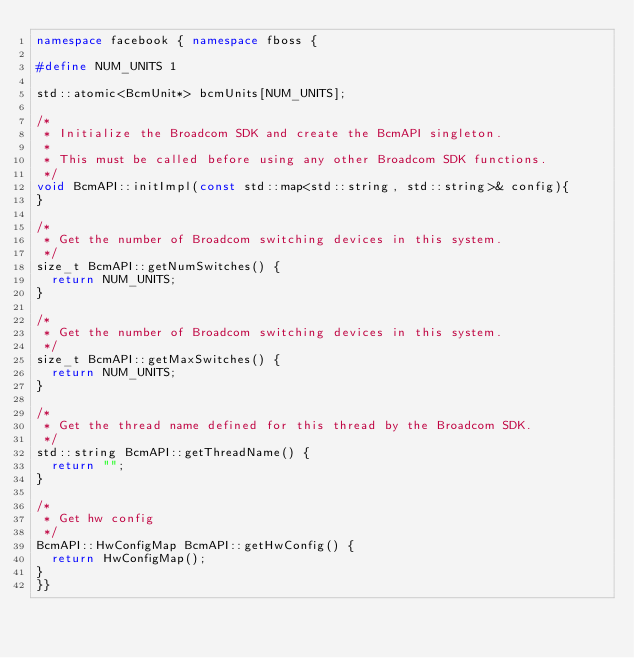<code> <loc_0><loc_0><loc_500><loc_500><_C++_>namespace facebook { namespace fboss {

#define NUM_UNITS 1

std::atomic<BcmUnit*> bcmUnits[NUM_UNITS];

/*
 * Initialize the Broadcom SDK and create the BcmAPI singleton.
 *
 * This must be called before using any other Broadcom SDK functions.
 */
void BcmAPI::initImpl(const std::map<std::string, std::string>& config){
}

/*
 * Get the number of Broadcom switching devices in this system.
 */
size_t BcmAPI::getNumSwitches() {
  return NUM_UNITS;
}

/*
 * Get the number of Broadcom switching devices in this system.
 */
size_t BcmAPI::getMaxSwitches() {
  return NUM_UNITS;
}

/*
 * Get the thread name defined for this thread by the Broadcom SDK.
 */
std::string BcmAPI::getThreadName() {
  return "";
}

/*
 * Get hw config
 */
BcmAPI::HwConfigMap BcmAPI::getHwConfig() {
  return HwConfigMap();
}
}}
</code> 